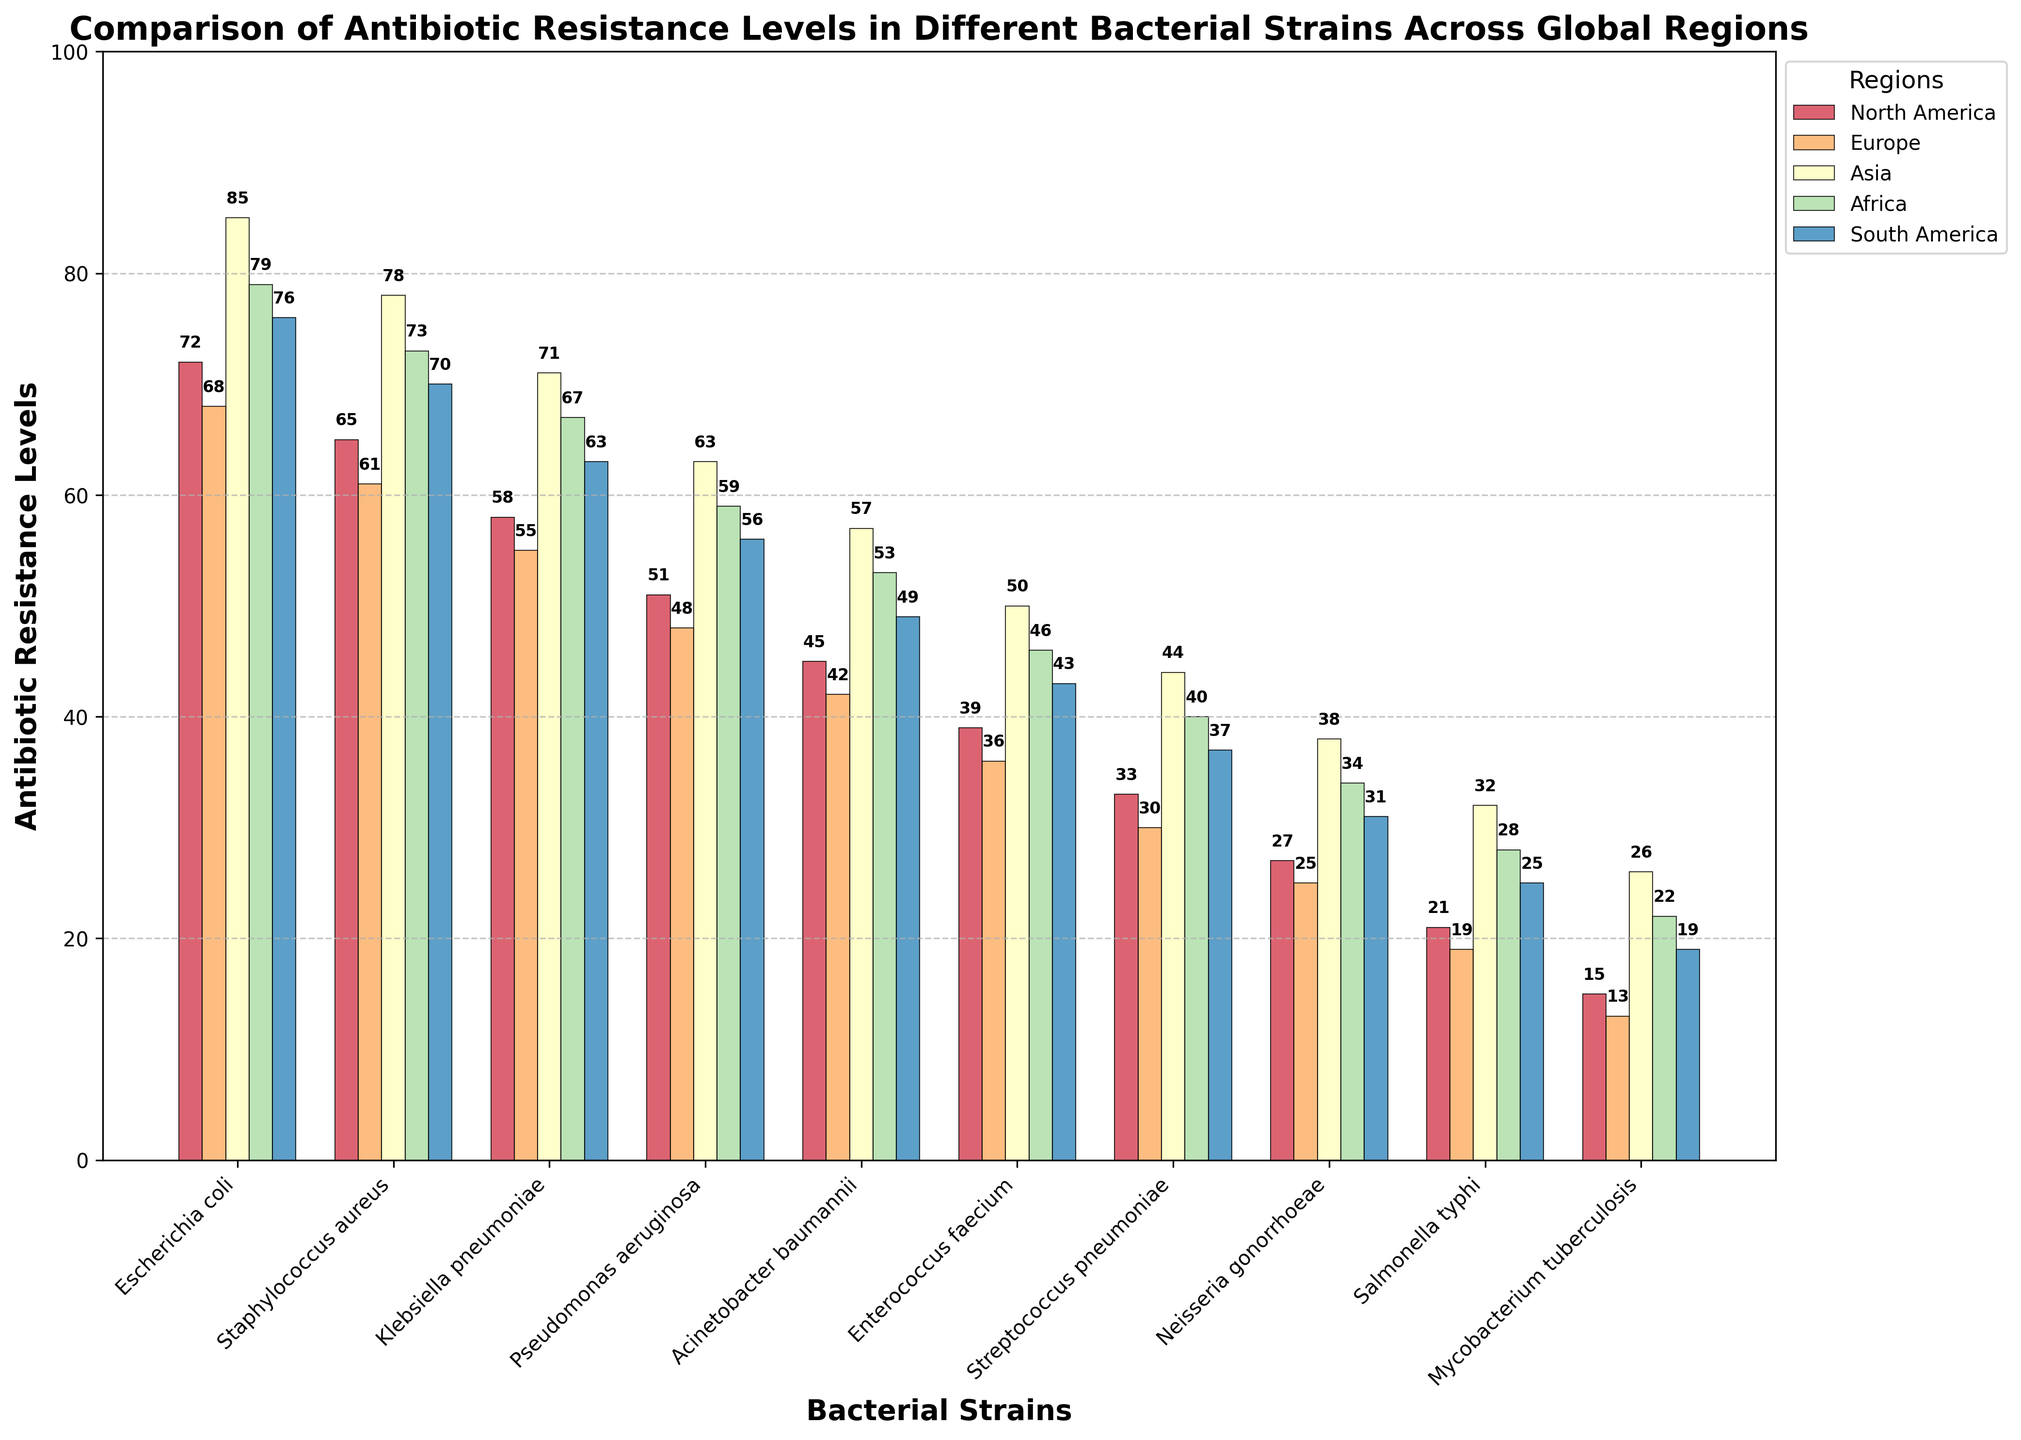What is the antibiotic resistance level of Escherichia coli in Asia? Locate the Escherichia coli bar and find the height corresponding to the "Asia" colored section. It is labeled with the value on top of the bar.
Answer: 85 Which region has the highest antibiotic resistance level for Staphylococcus aureus? Compare the heights of the bars representing different regions for the Staphylococcus aureus strain. The bar for Asia is the highest.
Answer: Asia Which bacterial strain has the lowest antibiotic resistance level in South America? Among all bars for South America, identify the one with the shortest height. It corresponds to Mycobacterium tuberculosis.
Answer: Mycobacterium tuberculosis What is the average antibiotic resistance level for Klebsiella pneumoniae across all regions? Add the resistance levels of Klebsiella pneumoniae across North America, Europe, Asia, Africa, and South America. Then divide the sum by the number of regions (5). (58+55+71+67+63) = 314, 314/5 = 62.8
Answer: 62.8 Compare the antibiotic resistance level of Pseudomonas aeruginosa in North America and Africa. Which one is higher? Find the bars for Pseudomonas aeruginosa in North America and Africa and compare their heights. The bar for North America is 51 and for Africa is 59; hence, Africa is higher.
Answer: Africa What is the total antibiotic resistance level for Enterococcus faecium in Europe and Asia? Add the resistance levels of Enterococcus faecium in Europe and Asia: 36 (Europe) + 50 (Asia) = 86.
Answer: 86 How many bacterial strains have an antibiotic resistance level higher than 50 in North America? Count the bars in the North America category that have heights greater than 50. They are: Escherichia coli, Staphylococcus aureus, Klebsiella pneumoniae, Pseudomonas aeruginosa. There are 4.
Answer: 4 Which bacterial strain has the closest resistance levels across all regions? Look for the bacterial strain with the most similar heights of bars across all regions, i.e., minimal differences between heights. Staphylococcus aureus displays relatively similar levels across regions (ranging from 61 to 78).
Answer: Staphylococcus aureus What is the difference in antibiotic resistance level of Neisseria gonorrhoeae between North America and Europe? Subtract the resistance level of Neisseria gonorrhoeae in Europe from that in North America: 27 (North America) - 25 (Europe) = 2.
Answer: 2 